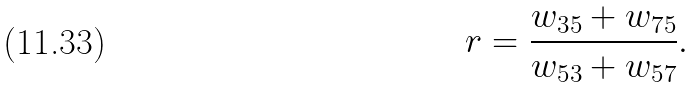Convert formula to latex. <formula><loc_0><loc_0><loc_500><loc_500>r = \frac { w _ { 3 5 } + w _ { 7 5 } } { w _ { 5 3 } + w _ { 5 7 } } .</formula> 